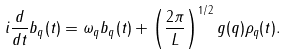<formula> <loc_0><loc_0><loc_500><loc_500>i \frac { d } { d t } b _ { q } ( t ) = \omega _ { q } b _ { q } ( t ) + \left ( \frac { 2 \pi } { L } \right ) ^ { 1 / 2 } g ( q ) \rho _ { q } ( t ) .</formula> 